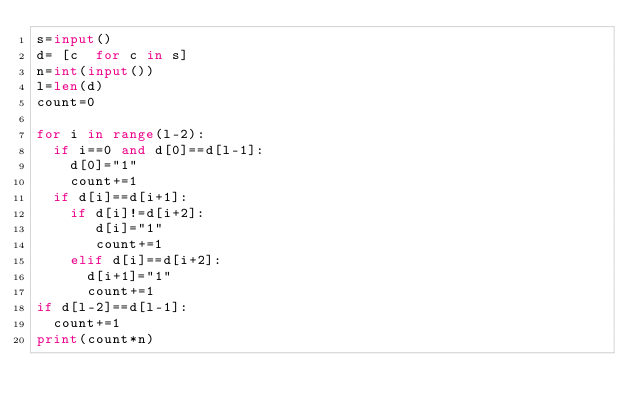<code> <loc_0><loc_0><loc_500><loc_500><_Python_>s=input()
d= [c  for c in s]
n=int(input())
l=len(d)
count=0

for i in range(l-2):
  if i==0 and d[0]==d[l-1]:
    d[0]="1"
    count+=1
  if d[i]==d[i+1]:
    if d[i]!=d[i+2]:
       d[i]="1"
       count+=1
    elif d[i]==d[i+2]:
      d[i+1]="1"
      count+=1
if d[l-2]==d[l-1]:
  count+=1
print(count*n)</code> 